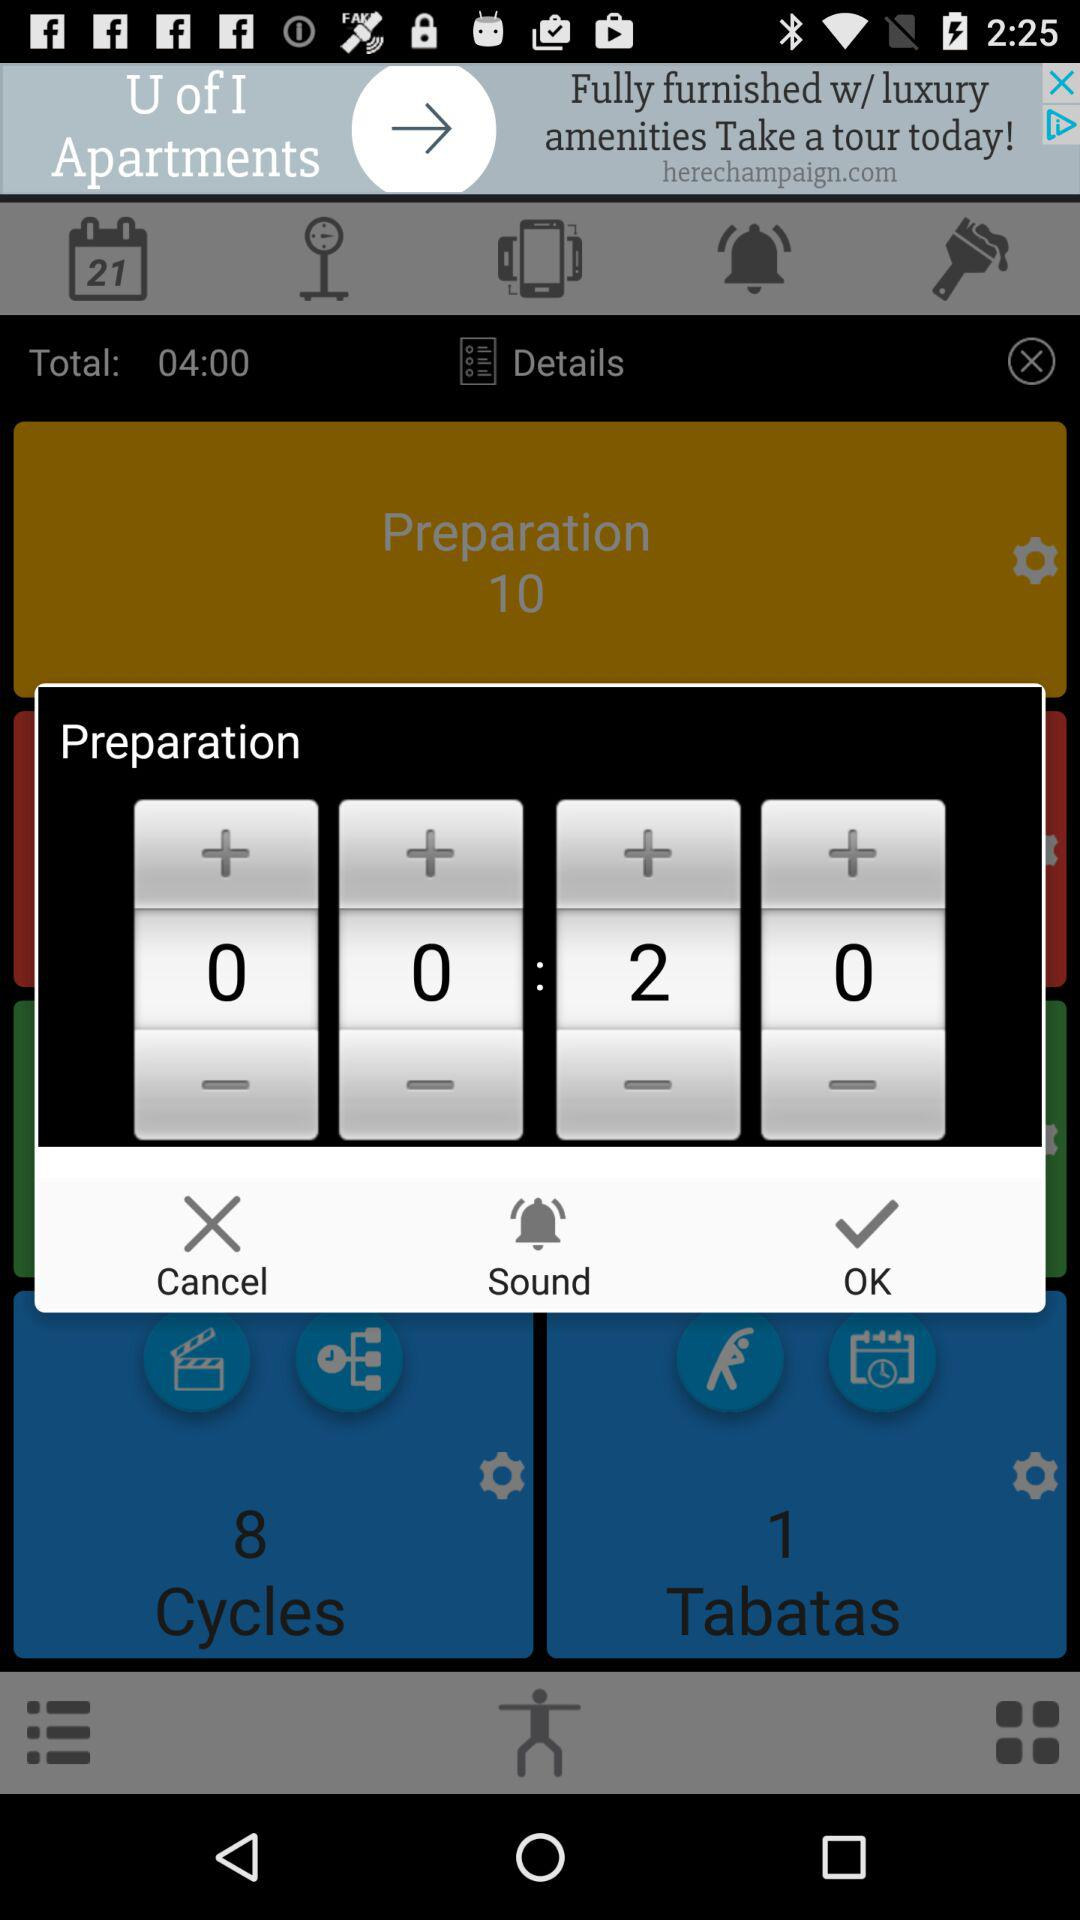What is the total time? The total time is 04:00. 